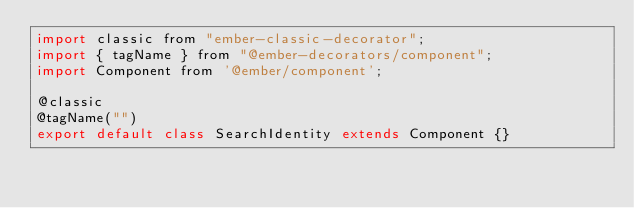<code> <loc_0><loc_0><loc_500><loc_500><_JavaScript_>import classic from "ember-classic-decorator";
import { tagName } from "@ember-decorators/component";
import Component from '@ember/component';

@classic
@tagName("")
export default class SearchIdentity extends Component {}
</code> 